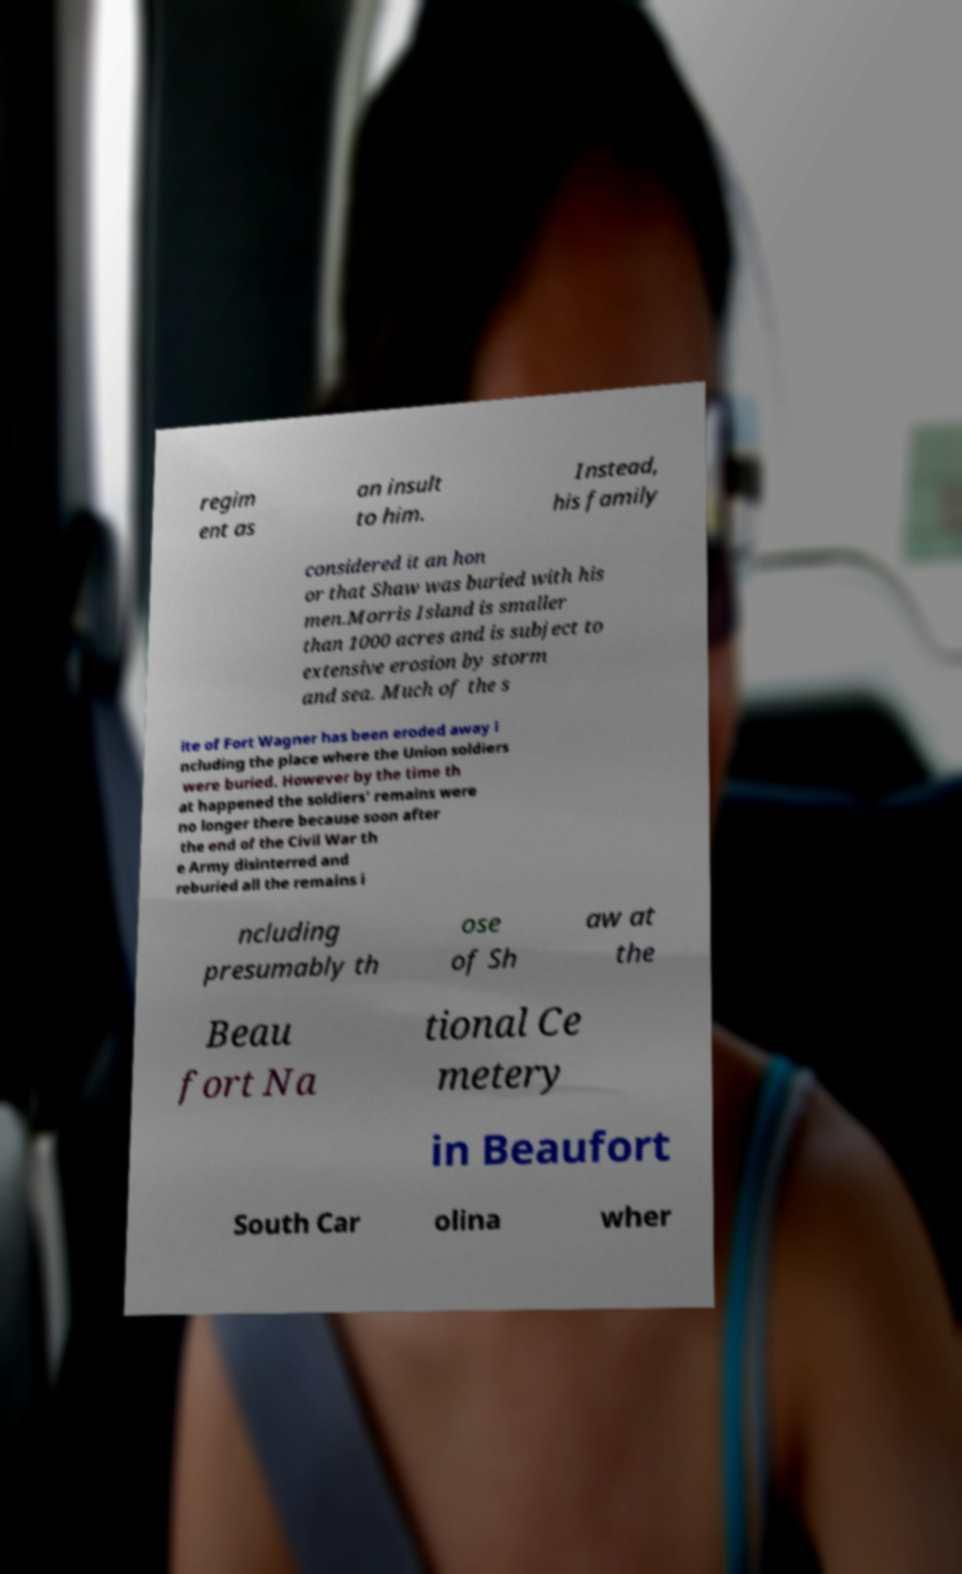Please read and relay the text visible in this image. What does it say? regim ent as an insult to him. Instead, his family considered it an hon or that Shaw was buried with his men.Morris Island is smaller than 1000 acres and is subject to extensive erosion by storm and sea. Much of the s ite of Fort Wagner has been eroded away i ncluding the place where the Union soldiers were buried. However by the time th at happened the soldiers' remains were no longer there because soon after the end of the Civil War th e Army disinterred and reburied all the remains i ncluding presumably th ose of Sh aw at the Beau fort Na tional Ce metery in Beaufort South Car olina wher 